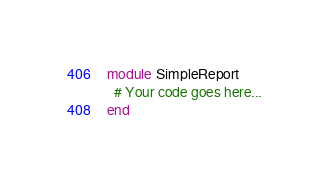Convert code to text. <code><loc_0><loc_0><loc_500><loc_500><_Ruby_>module SimpleReport
  # Your code goes here...
end
</code> 